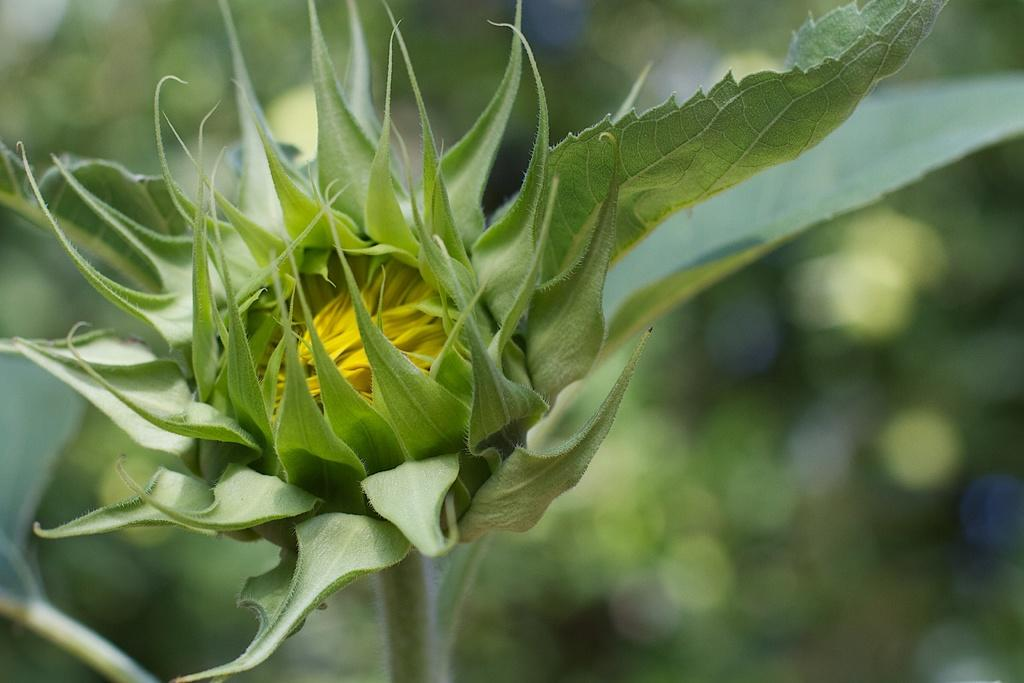What is the main subject of the image? The main subject of the image is a bud. Can you describe the background of the image? The background of the image is blurred. What type of house can be seen on the coast during the holiday in the image? There is no house, coast, or holiday depicted in the image; it only features a bud with a blurred background. 